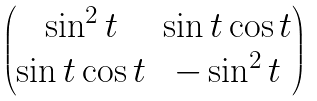Convert formula to latex. <formula><loc_0><loc_0><loc_500><loc_500>\begin{pmatrix} \sin ^ { 2 } t & \sin t \cos t \\ \sin t \cos t & - \sin ^ { 2 } t \end{pmatrix}</formula> 